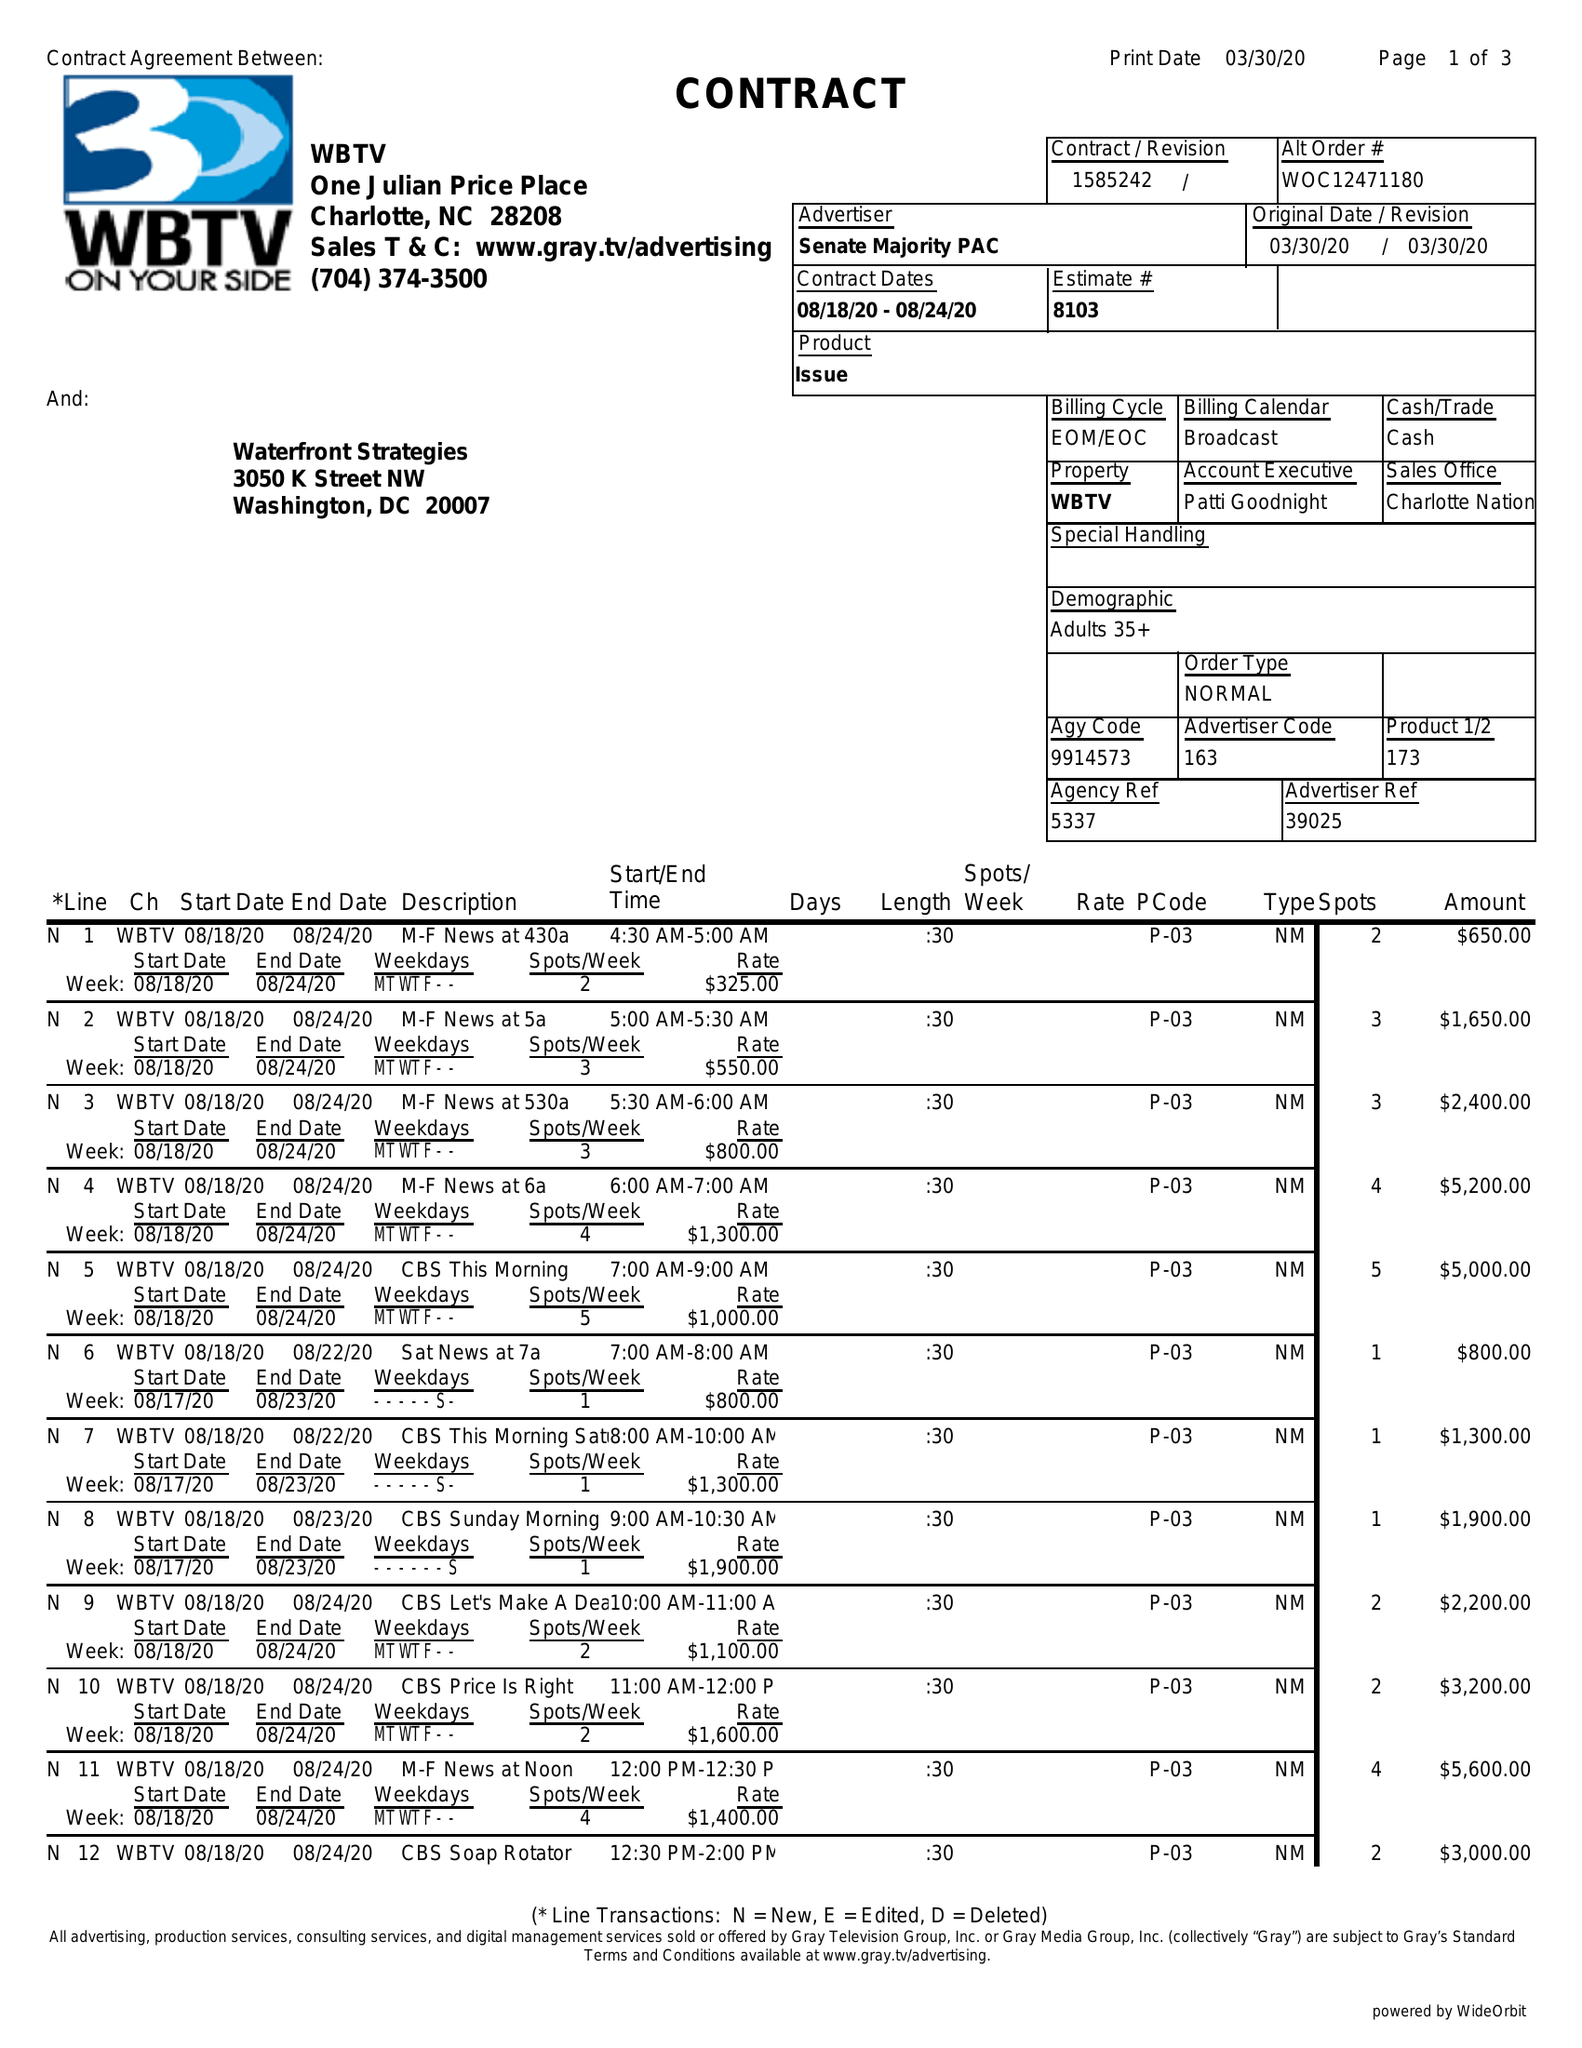What is the value for the contract_num?
Answer the question using a single word or phrase. 1585242 